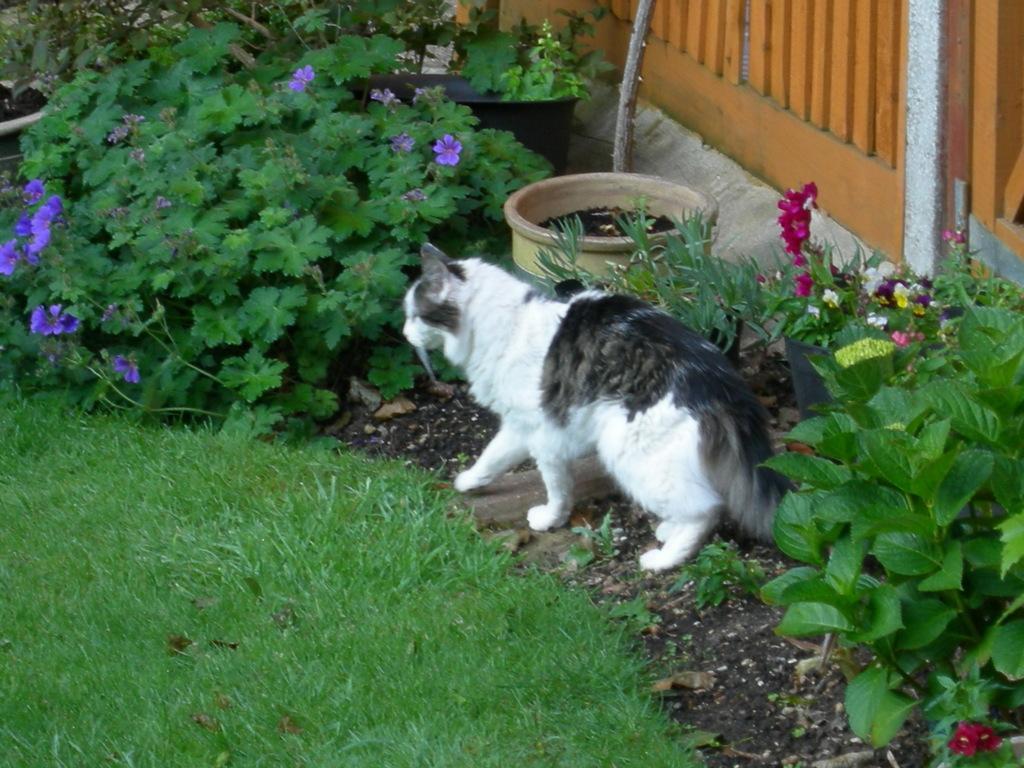Could you give a brief overview of what you see in this image? In this image in front there is grass on the surface. There are plants with the flowers on it. There is a cat. At the right side of the image we can see a wooden fence. 